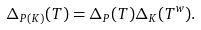<formula> <loc_0><loc_0><loc_500><loc_500>\Delta _ { P ( K ) } ( T ) = \Delta _ { P } ( T ) \Delta _ { K } ( T ^ { w } ) .</formula> 